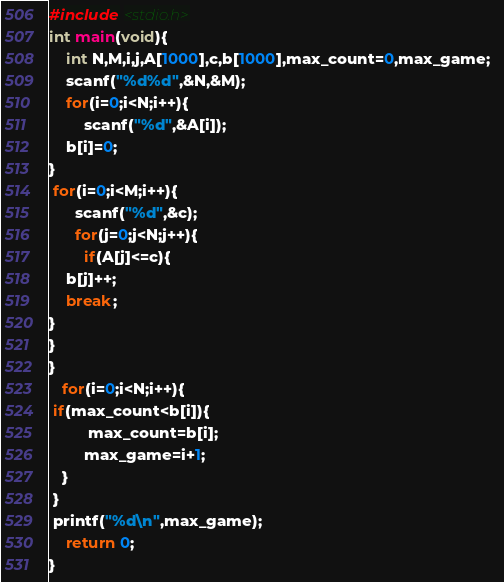<code> <loc_0><loc_0><loc_500><loc_500><_C_>


#include <stdio.h>
int main(void){    
	int N,M,i,j,A[1000],c,b[1000],max_count=0,max_game;  
	scanf("%d%d",&N,&M);  
	for(i=0;i<N;i++){  
        scanf("%d",&A[i]);          
	b[i]=0;   
}    
 for(i=0;i<M;i++){   
      scanf("%d",&c);   
      for(j=0;j<N;j++){     
        if(A[j]<=c){
	b[j]++;
	break;
}   
} 
}    
   for(i=0;i<N;i++){        
 if(max_count<b[i]){    
         max_count=b[i];     
        max_game=i+1;      
   }    
 }      
 printf("%d\n",max_game);
	return 0;
} </code> 